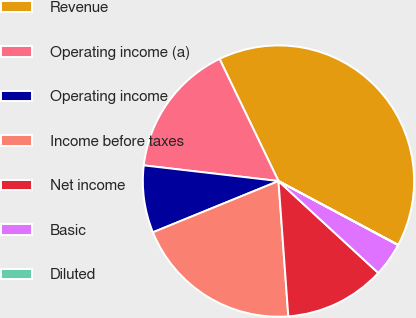<chart> <loc_0><loc_0><loc_500><loc_500><pie_chart><fcel>Revenue<fcel>Operating income (a)<fcel>Operating income<fcel>Income before taxes<fcel>Net income<fcel>Basic<fcel>Diluted<nl><fcel>39.95%<fcel>16.0%<fcel>8.01%<fcel>19.99%<fcel>12.0%<fcel>4.02%<fcel>0.03%<nl></chart> 